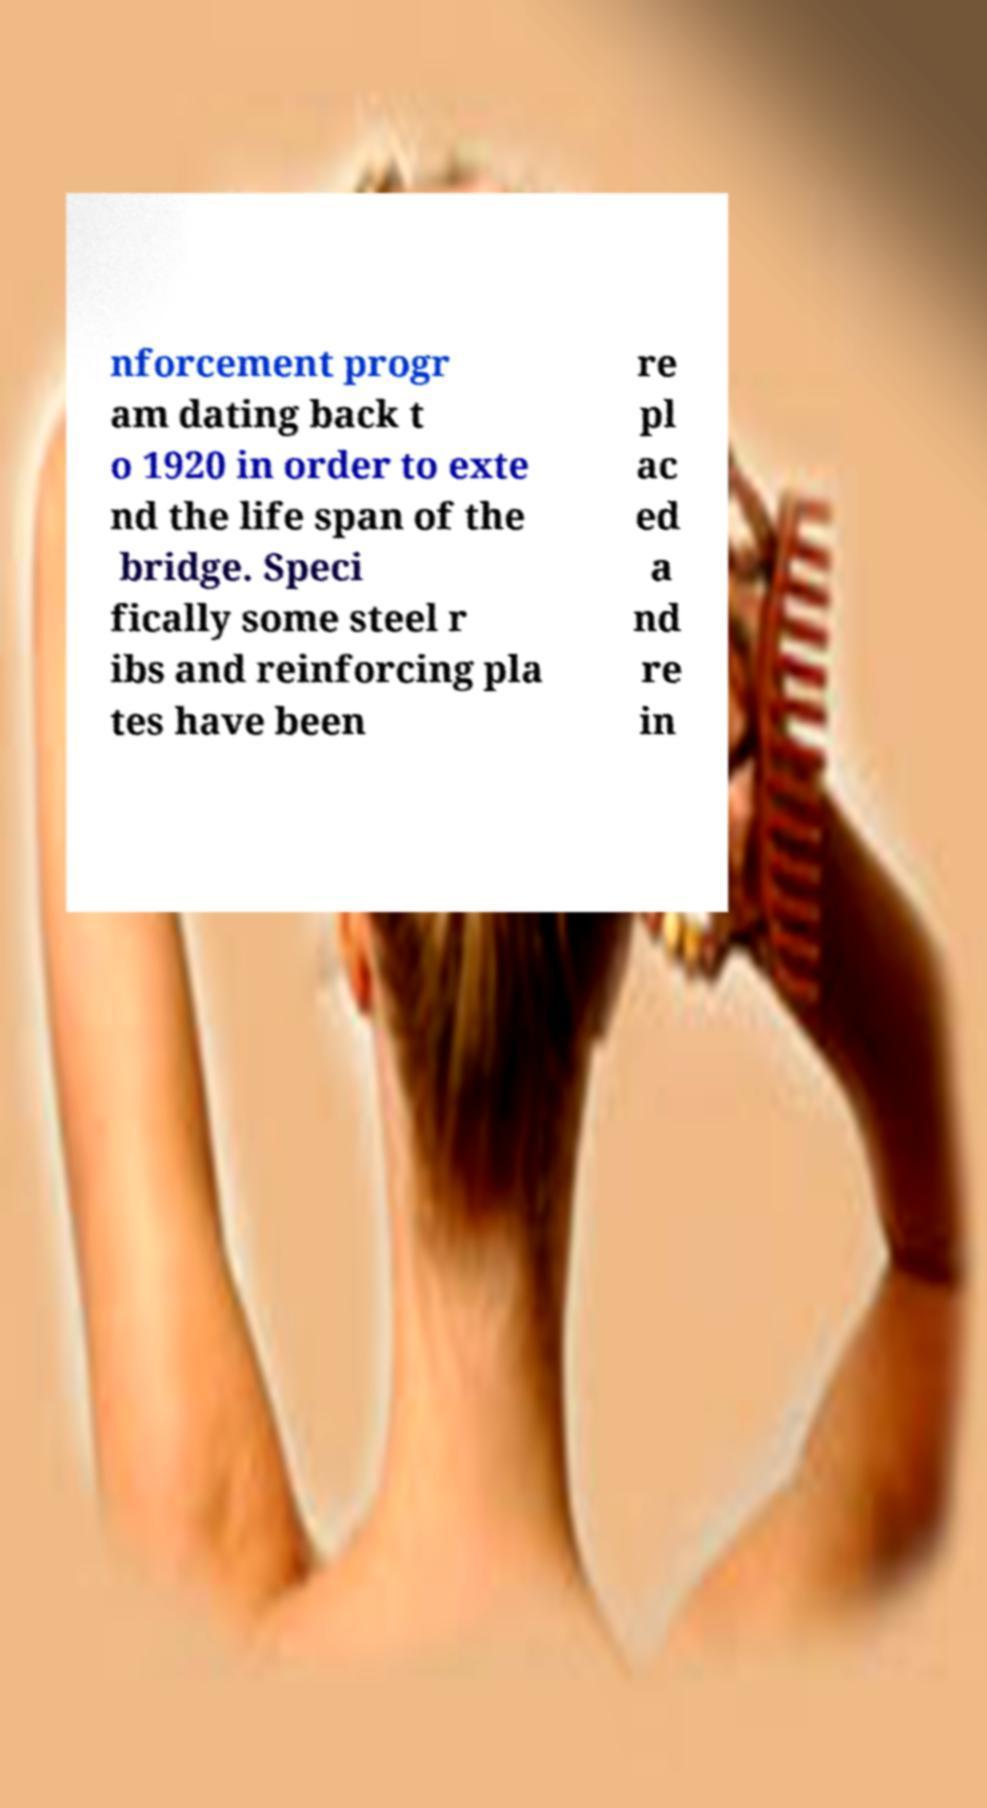What messages or text are displayed in this image? I need them in a readable, typed format. nforcement progr am dating back t o 1920 in order to exte nd the life span of the bridge. Speci fically some steel r ibs and reinforcing pla tes have been re pl ac ed a nd re in 